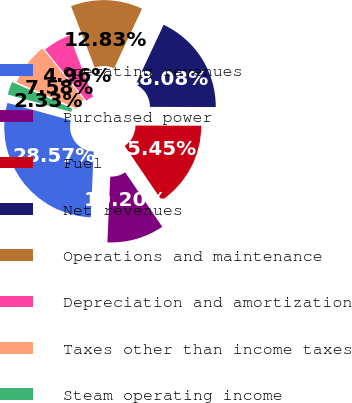Convert chart. <chart><loc_0><loc_0><loc_500><loc_500><pie_chart><fcel>Operating revenues<fcel>Purchased power<fcel>Fuel<fcel>Net revenues<fcel>Operations and maintenance<fcel>Depreciation and amortization<fcel>Taxes other than income taxes<fcel>Steam operating income<nl><fcel>28.57%<fcel>10.2%<fcel>15.45%<fcel>18.08%<fcel>12.83%<fcel>4.96%<fcel>7.58%<fcel>2.33%<nl></chart> 